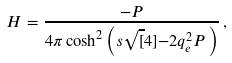<formula> <loc_0><loc_0><loc_500><loc_500>H = \frac { - P } { 4 \pi \cosh ^ { 2 } \left ( s \sqrt { [ } 4 ] { - 2 q _ { e } ^ { 2 } P } \, \right ) } \, ,</formula> 